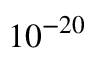<formula> <loc_0><loc_0><loc_500><loc_500>1 0 ^ { - 2 0 }</formula> 